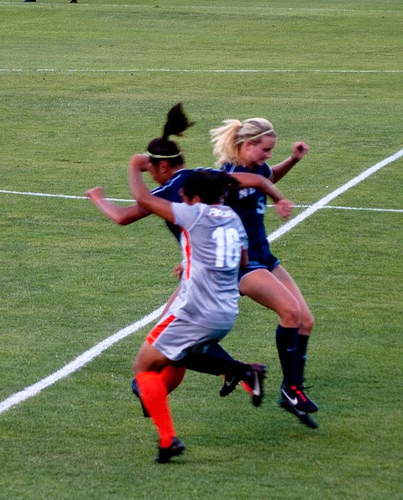<image>
Is there a shoes on the person? Yes. Looking at the image, I can see the shoes is positioned on top of the person, with the person providing support. 